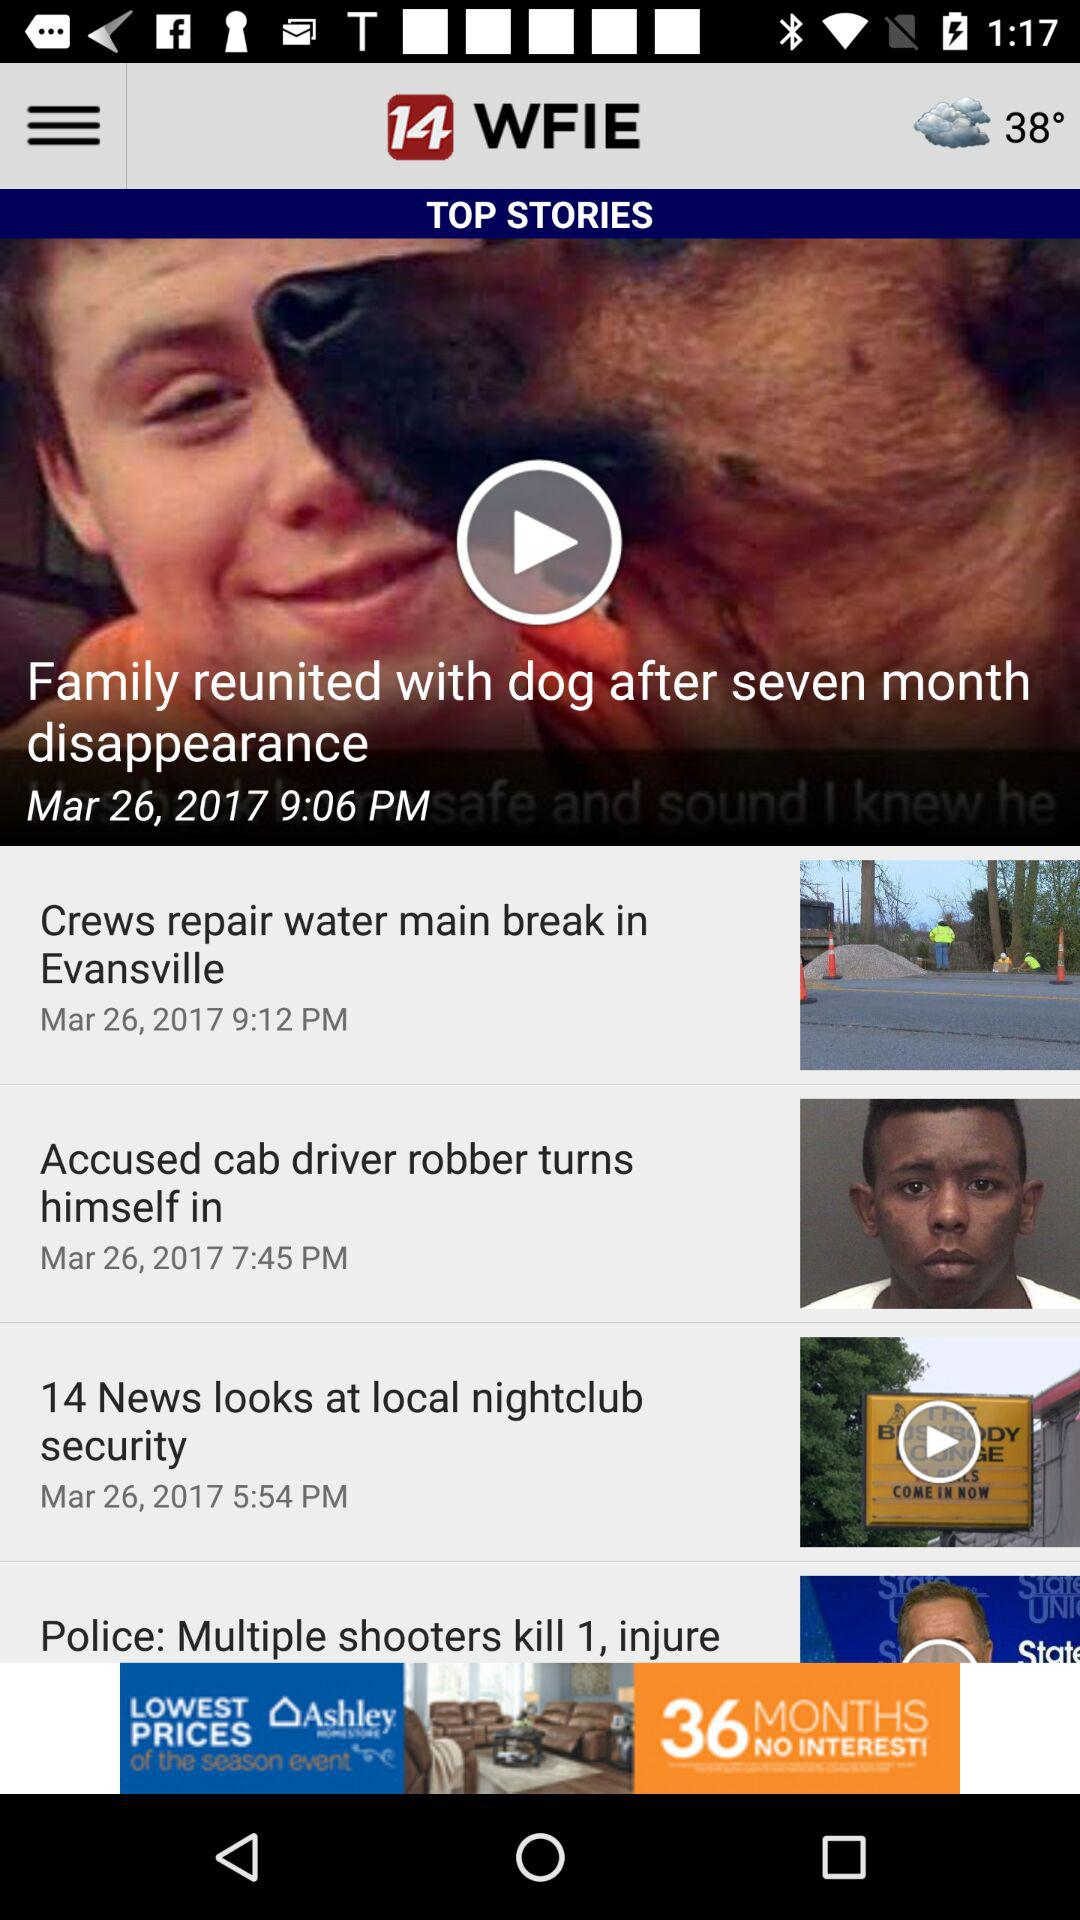What information was published on March 26, 2017 at 5:54 PM? The information published was "14 News looks at local nightclub security". 